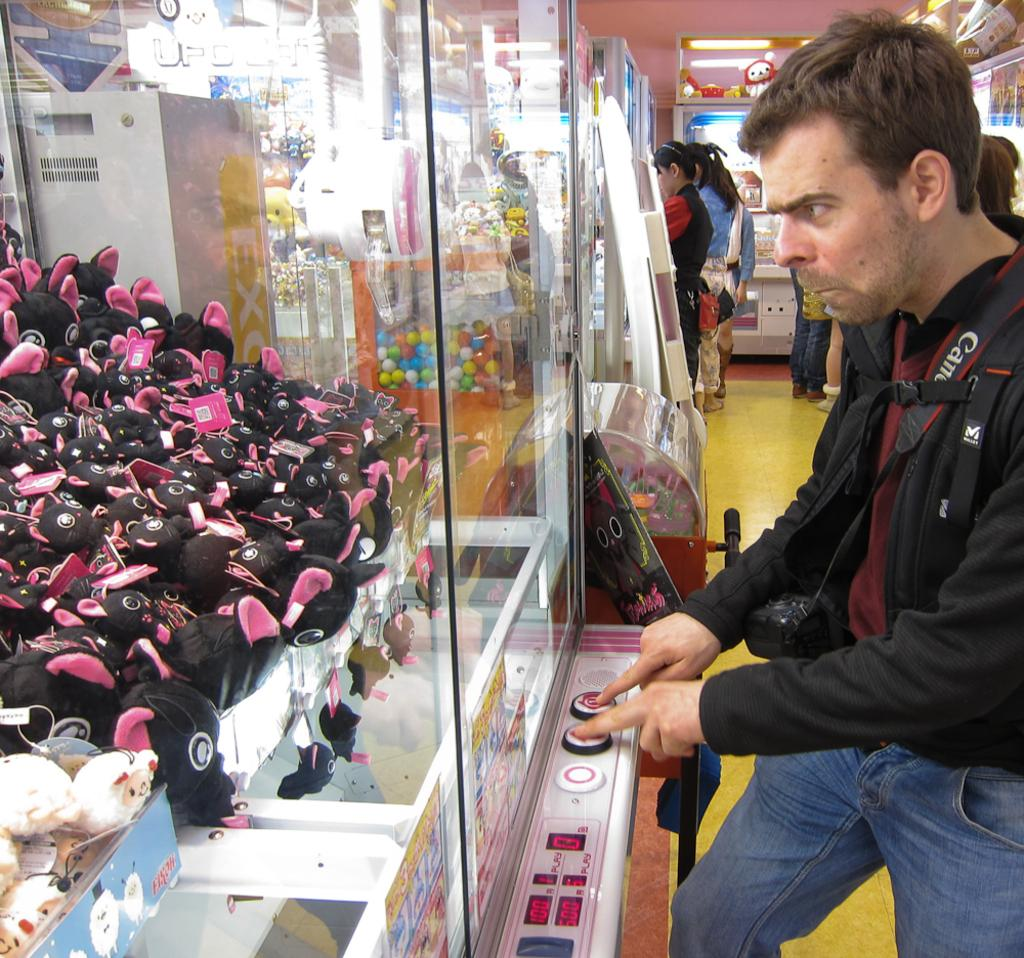What objects are contained within glass boxes in the image? There are toys in glass boxes in the image. What is the person in the image doing? The person is standing and pressing buttons in the image. What can be seen in the background of the image? There are toys and a group of people visible in the background of the image. What type of garden can be seen in the image? There is no garden present in the image. How many basins are visible in the image? There are no basins visible in the image. 